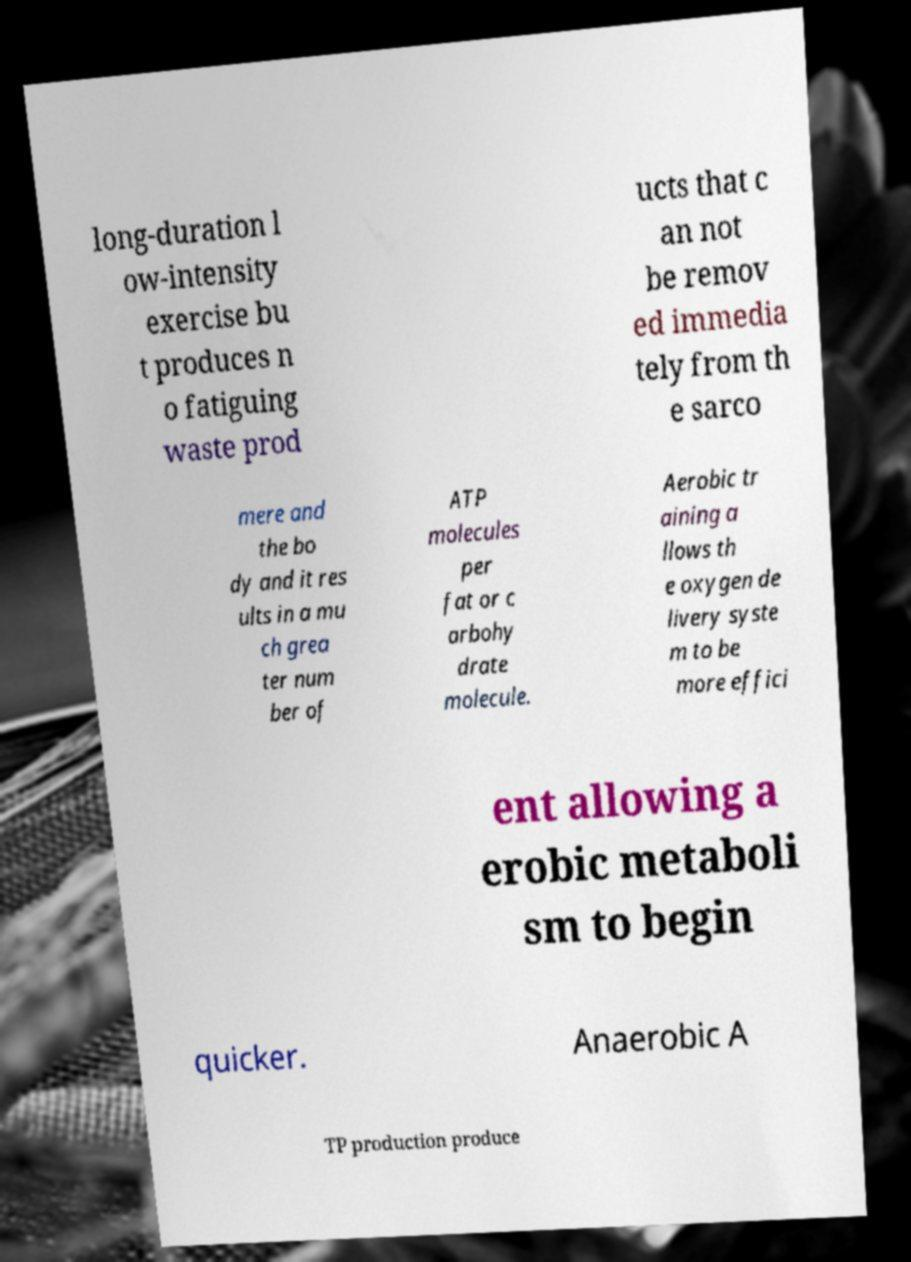Can you read and provide the text displayed in the image?This photo seems to have some interesting text. Can you extract and type it out for me? long-duration l ow-intensity exercise bu t produces n o fatiguing waste prod ucts that c an not be remov ed immedia tely from th e sarco mere and the bo dy and it res ults in a mu ch grea ter num ber of ATP molecules per fat or c arbohy drate molecule. Aerobic tr aining a llows th e oxygen de livery syste m to be more effici ent allowing a erobic metaboli sm to begin quicker. Anaerobic A TP production produce 